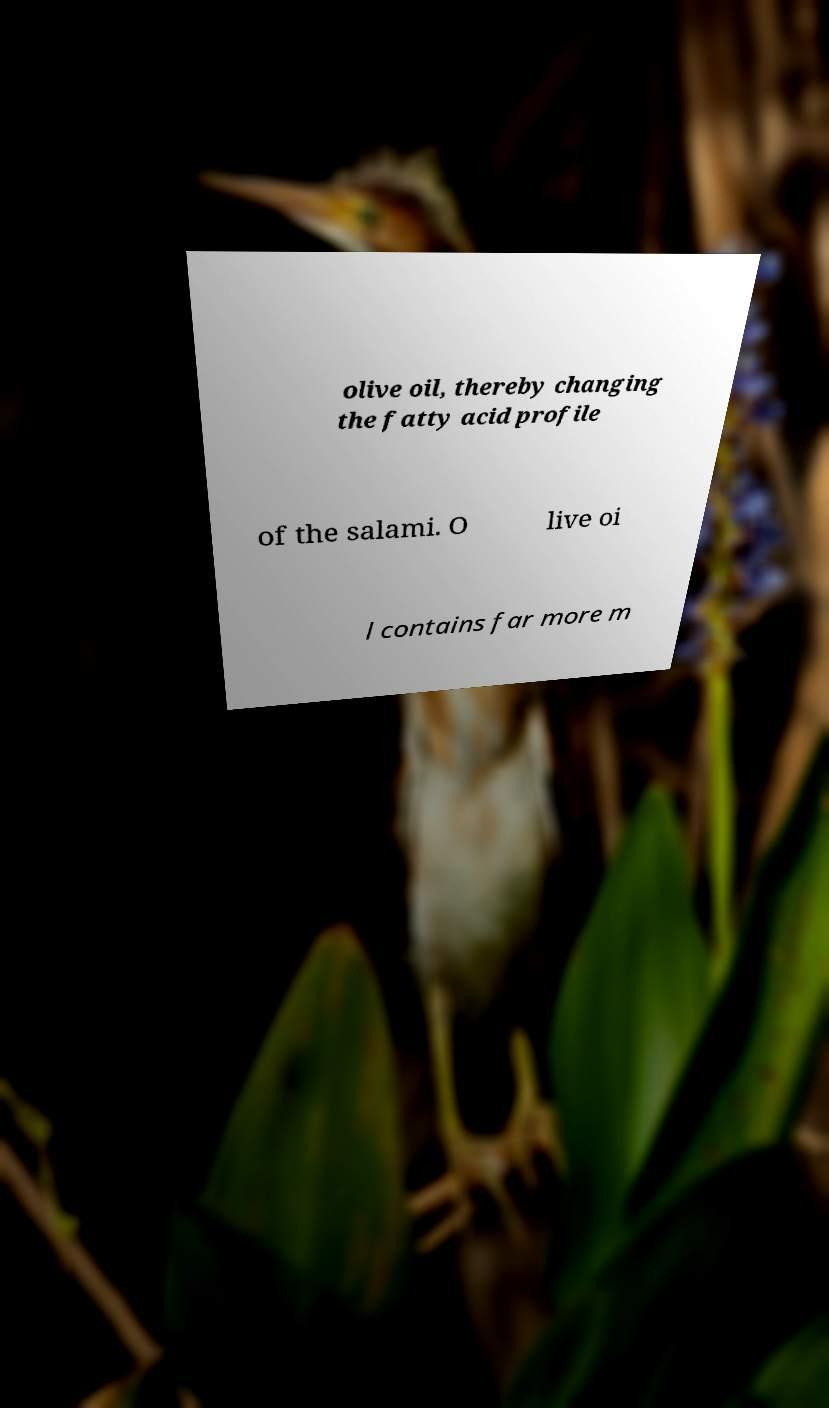There's text embedded in this image that I need extracted. Can you transcribe it verbatim? olive oil, thereby changing the fatty acid profile of the salami. O live oi l contains far more m 